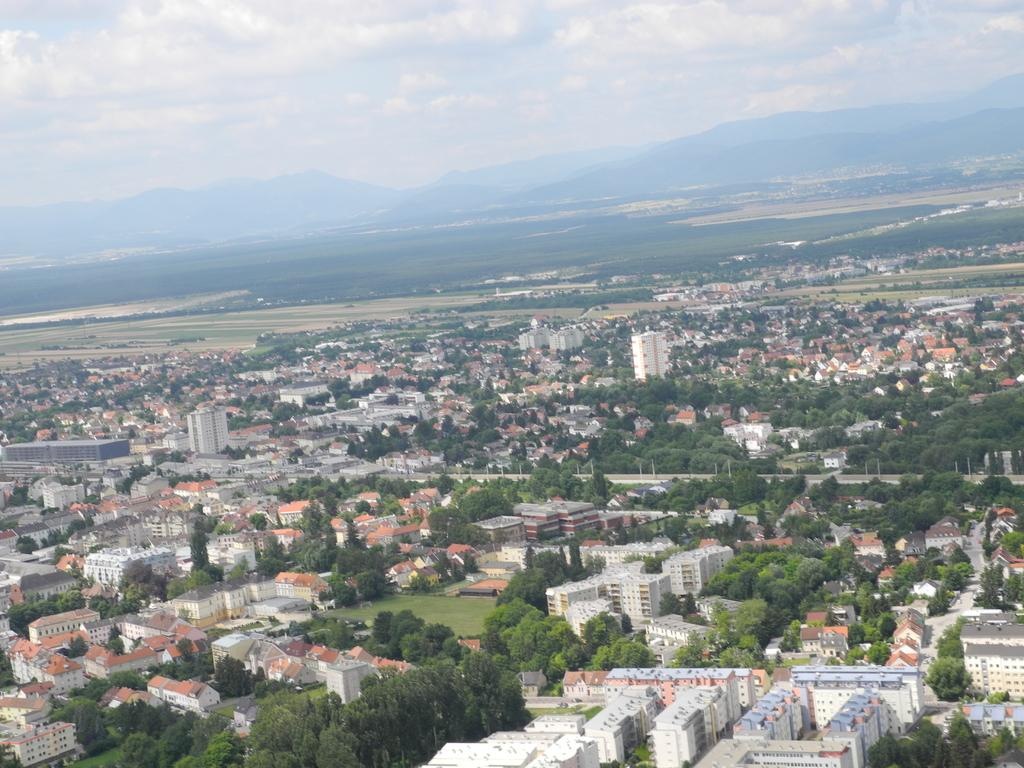What type of view is depicted in the image? The image is an aerial view. What structures can be seen in the image? There are buildings in the image. What type of vegetation is present in the image? There are trees and grass in the image. What type of land use can be observed in the image? There are farmlands in the image. What geographical features are visible in the image? There are hills in the image. What is visible in the sky in the image? The sky is visible in the image, and clouds are present. What is the condition of the potatoes in the image? There are no potatoes present in the image. What day of the week is depicted in the image? The image does not depict a specific day of the week; it is a still image of a landscape. 